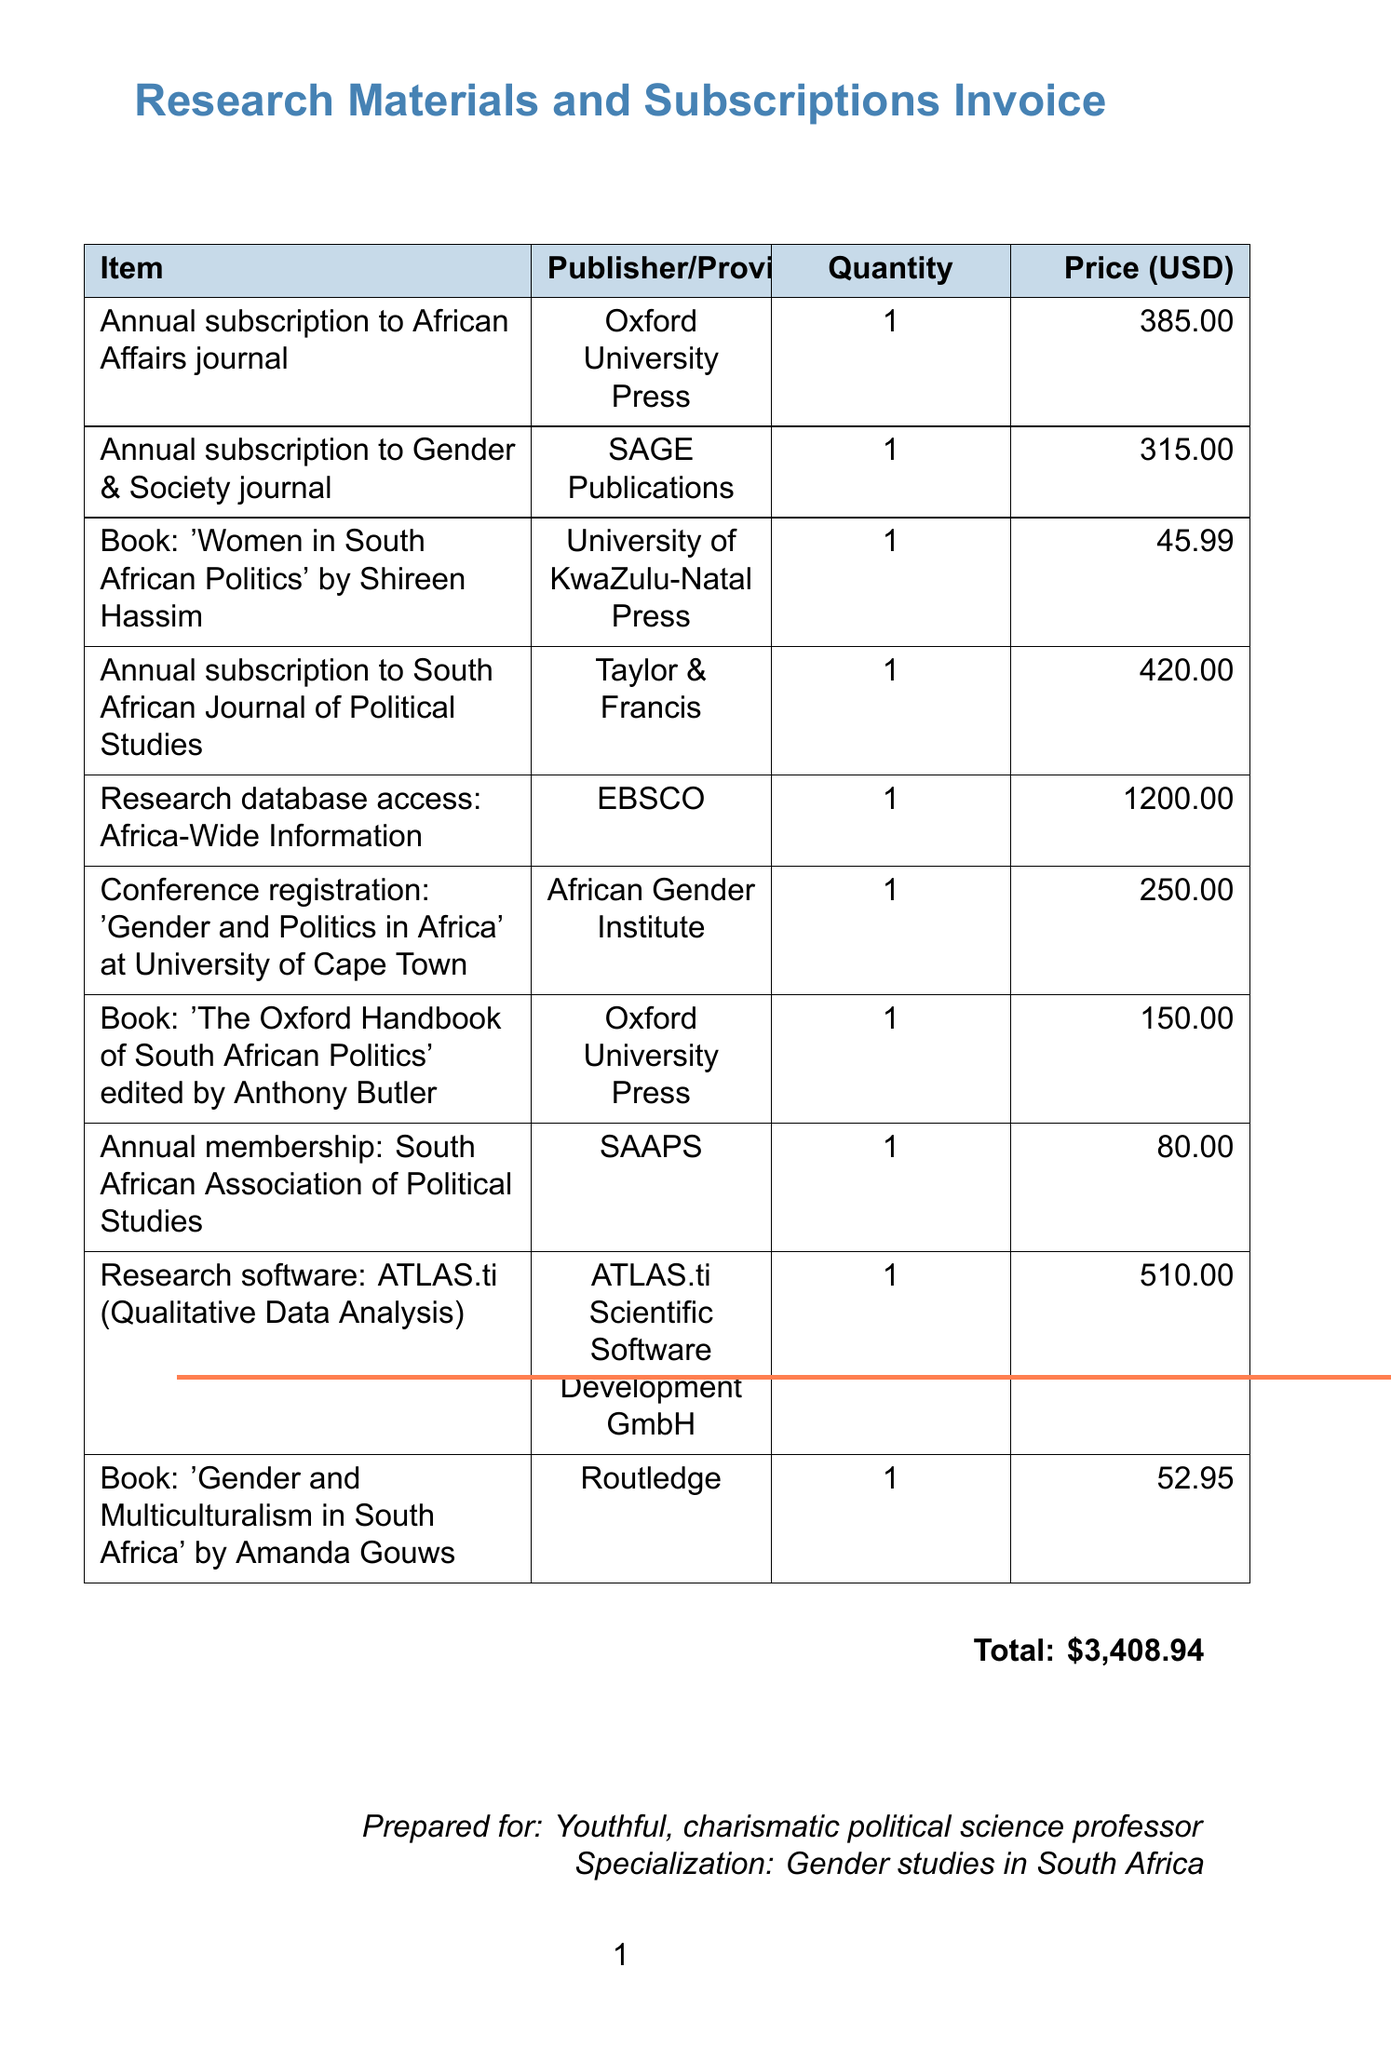What is the total amount of the invoice? The total amount is listed at the bottom of the invoice, which is the sum of all individual item prices.
Answer: $3,408.94 Who is the publisher of the book 'Women in South African Politics'? The publisher of the book is indicated next to the item description in the invoice.
Answer: University of KwaZulu-Natal Press How much does the annual subscription to the Gender & Society journal cost? The cost of this subscription is provided in the price column of the invoice.
Answer: 315.00 What type of database access is included in the invoice? This is mentioned explicitly in the item description in the document.
Answer: Africa-Wide Information Which organization is managing the conference registration? The invoice specifies the organizer of the conference, which is mentioned next to the registration item.
Answer: African Gender Institute What was the unit price of the book 'Gender and Multiculturalism in South Africa'? The unit price is indicated next to the item description on the invoice.
Answer: 52.95 How many items are listed in the invoice? The total number of invoice items can be counted from the item list provided in the document.
Answer: 10 What is the annual membership fee for the South African Association of Political Studies? The fee is clearly stated in the unit price column for the membership item in the invoice.
Answer: 80.00 Which journal is published by Oxford University Press? The specific journal is stated in the item description under the publisher’s name in the document.
Answer: African Affairs 